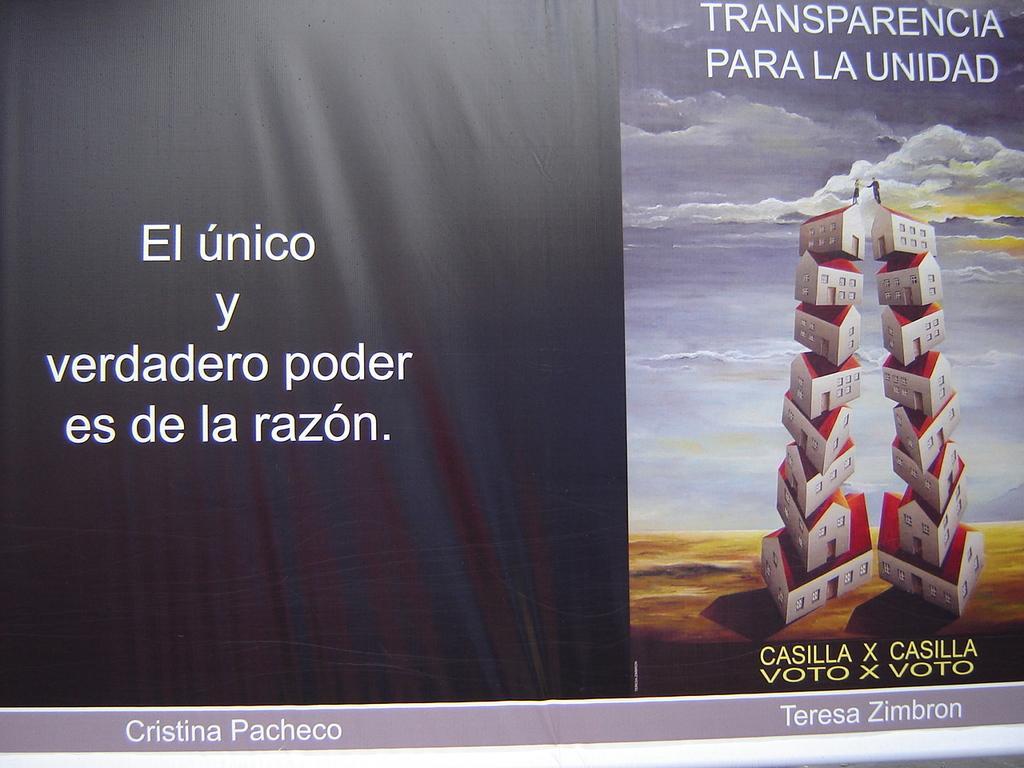Could you give a brief overview of what you see in this image? In this image I can see a huge banner which is black and white in color and I can see a picture in which I can see few buildings which are red and white in color on on the other and I can see two persons on top of the buildings. In the background I can see the sky. 